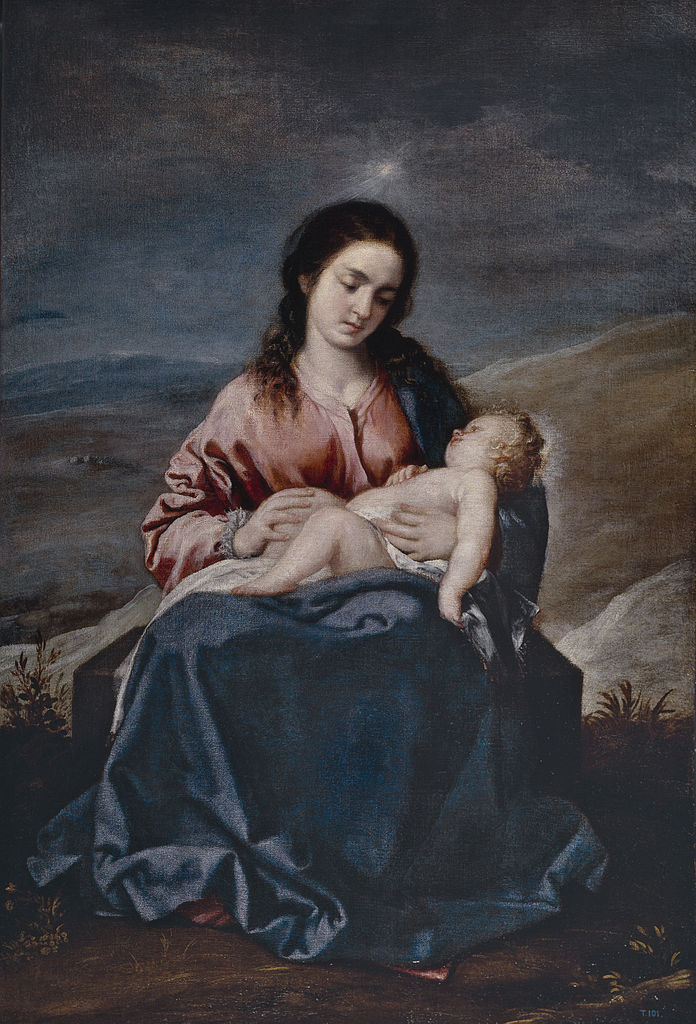If this painting could tell a story beyond its visual scene, what tale might it unfold? Beyond the tranquil visual scene, this painting could unfold the tale of a miraculous journey. It might tell of a young mother and her divine child, traveling through a rugged, darkened landscape, facing adversities with the light of hope guiding them. The woman, embodying strength and grace, finds solace in her child's presence, while the child, serene and wise beyond his years, brings comfort and light to those they encounter. Their journey could lead them to distant lands, touching lives and spreading a message of compassion, unity, and faith. Each brushstroke, then, isn’t just about portraying a moment, but about capturing the essence of an enduring legacy that transcends time and place. 